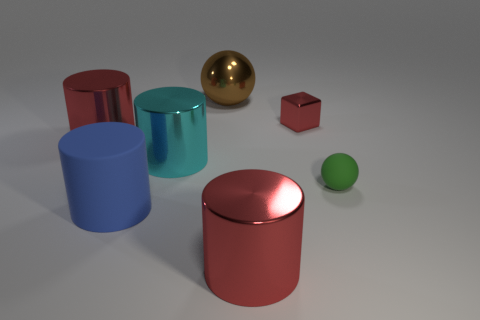Subtract all yellow spheres. How many red cylinders are left? 2 Subtract all large blue cylinders. How many cylinders are left? 3 Add 1 green matte objects. How many objects exist? 8 Subtract all blocks. How many objects are left? 6 Subtract all gray cylinders. Subtract all yellow blocks. How many cylinders are left? 4 Subtract all large cyan things. Subtract all big matte objects. How many objects are left? 5 Add 1 big things. How many big things are left? 6 Add 5 matte things. How many matte things exist? 7 Subtract 1 blue cylinders. How many objects are left? 6 